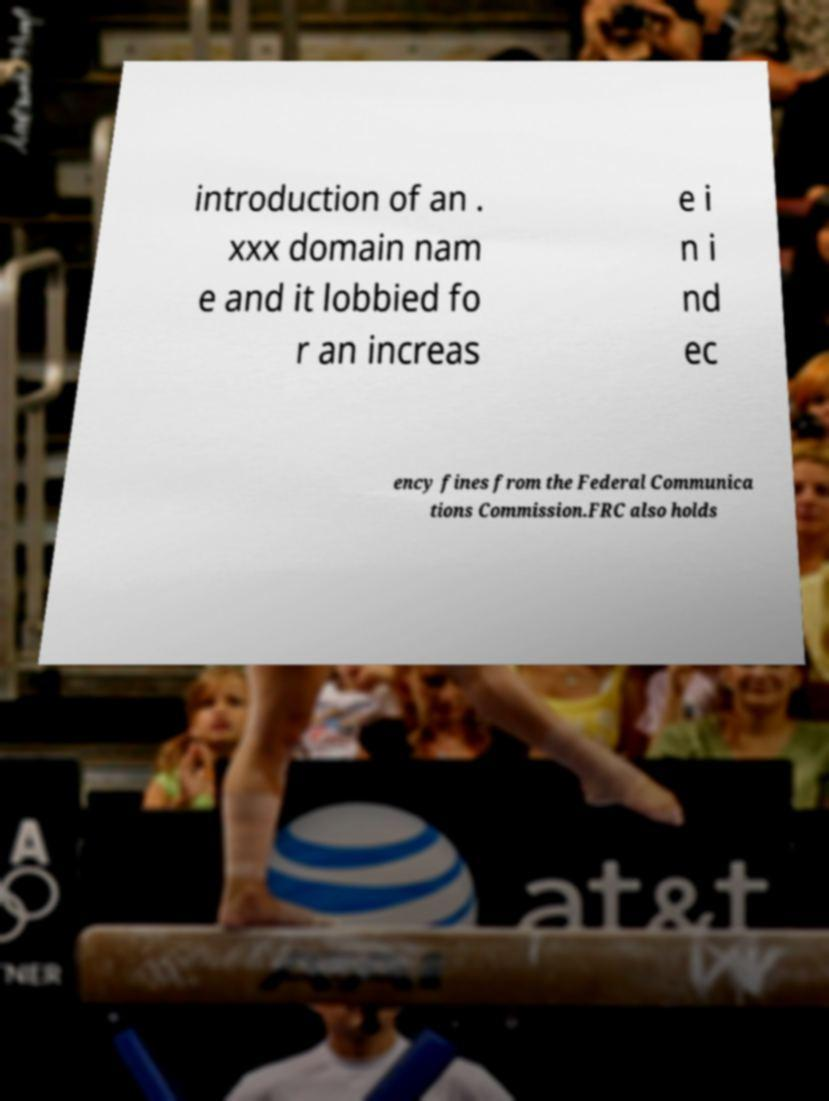There's text embedded in this image that I need extracted. Can you transcribe it verbatim? introduction of an . xxx domain nam e and it lobbied fo r an increas e i n i nd ec ency fines from the Federal Communica tions Commission.FRC also holds 